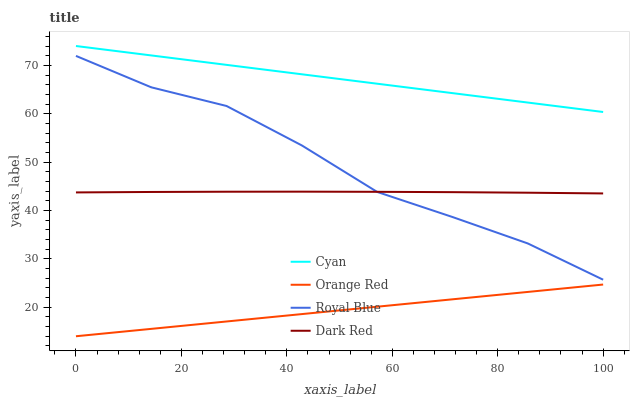Does Orange Red have the minimum area under the curve?
Answer yes or no. Yes. Does Cyan have the maximum area under the curve?
Answer yes or no. Yes. Does Dark Red have the minimum area under the curve?
Answer yes or no. No. Does Dark Red have the maximum area under the curve?
Answer yes or no. No. Is Orange Red the smoothest?
Answer yes or no. Yes. Is Royal Blue the roughest?
Answer yes or no. Yes. Is Dark Red the smoothest?
Answer yes or no. No. Is Dark Red the roughest?
Answer yes or no. No. Does Orange Red have the lowest value?
Answer yes or no. Yes. Does Dark Red have the lowest value?
Answer yes or no. No. Does Cyan have the highest value?
Answer yes or no. Yes. Does Dark Red have the highest value?
Answer yes or no. No. Is Orange Red less than Cyan?
Answer yes or no. Yes. Is Cyan greater than Orange Red?
Answer yes or no. Yes. Does Dark Red intersect Royal Blue?
Answer yes or no. Yes. Is Dark Red less than Royal Blue?
Answer yes or no. No. Is Dark Red greater than Royal Blue?
Answer yes or no. No. Does Orange Red intersect Cyan?
Answer yes or no. No. 